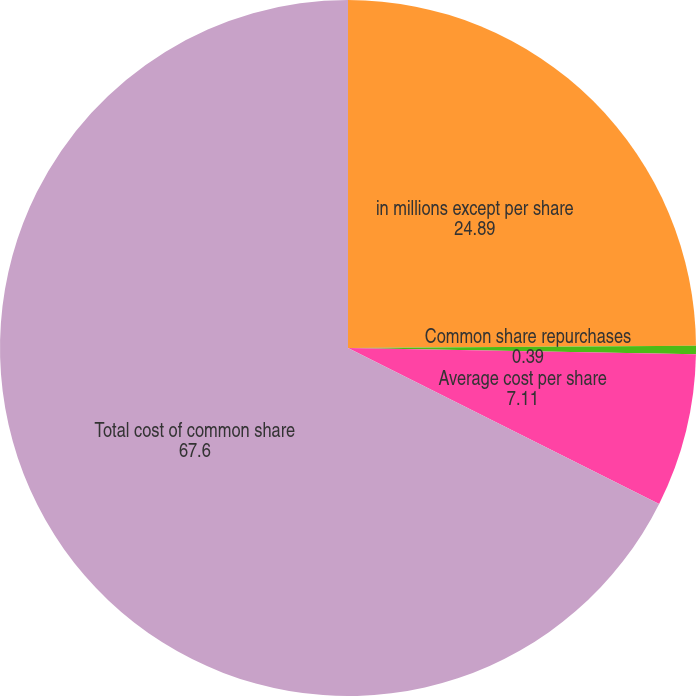<chart> <loc_0><loc_0><loc_500><loc_500><pie_chart><fcel>in millions except per share<fcel>Common share repurchases<fcel>Average cost per share<fcel>Total cost of common share<nl><fcel>24.89%<fcel>0.39%<fcel>7.11%<fcel>67.6%<nl></chart> 